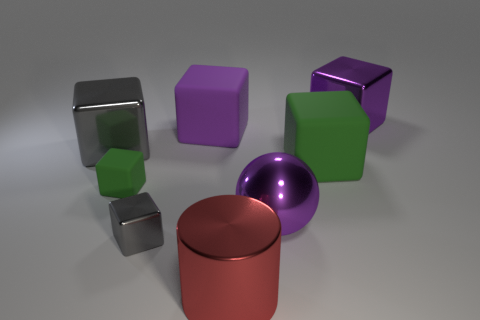What is the material of the gray block right of the metal cube left of the small green block?
Ensure brevity in your answer.  Metal. Is the number of green objects behind the tiny green block greater than the number of small purple metal cylinders?
Provide a short and direct response. Yes. What number of other things are the same size as the sphere?
Offer a terse response. 5. There is a object behind the purple block in front of the large purple cube that is on the right side of the big green block; what color is it?
Your answer should be very brief. Purple. How many matte objects are behind the gray metallic object to the left of the green cube that is on the left side of the large shiny cylinder?
Offer a very short reply. 1. Is there anything else that is the same color as the big shiny cylinder?
Ensure brevity in your answer.  No. Does the green thing to the right of the metal cylinder have the same size as the small gray object?
Ensure brevity in your answer.  No. There is a shiny thing to the left of the tiny shiny block; how many large metallic objects are in front of it?
Offer a terse response. 2. There is a big purple metal object to the left of the shiny cube that is behind the big gray metallic cube; are there any small green objects that are behind it?
Provide a succinct answer. Yes. There is a large gray object that is the same shape as the tiny metal thing; what material is it?
Provide a succinct answer. Metal. 